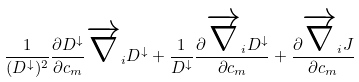Convert formula to latex. <formula><loc_0><loc_0><loc_500><loc_500>\frac { 1 } { ( D ^ { \downarrow } ) ^ { 2 } } \frac { \partial D ^ { \downarrow } } { \partial c _ { m } } \overrightarrow { \nabla } _ { i } D ^ { \downarrow } + \frac { 1 } { D ^ { \downarrow } } \frac { \partial \overrightarrow { \nabla } _ { i } D ^ { \downarrow } } { \partial c _ { m } } + \frac { \partial \overrightarrow { \nabla } _ { i } J } { \partial c _ { m } }</formula> 